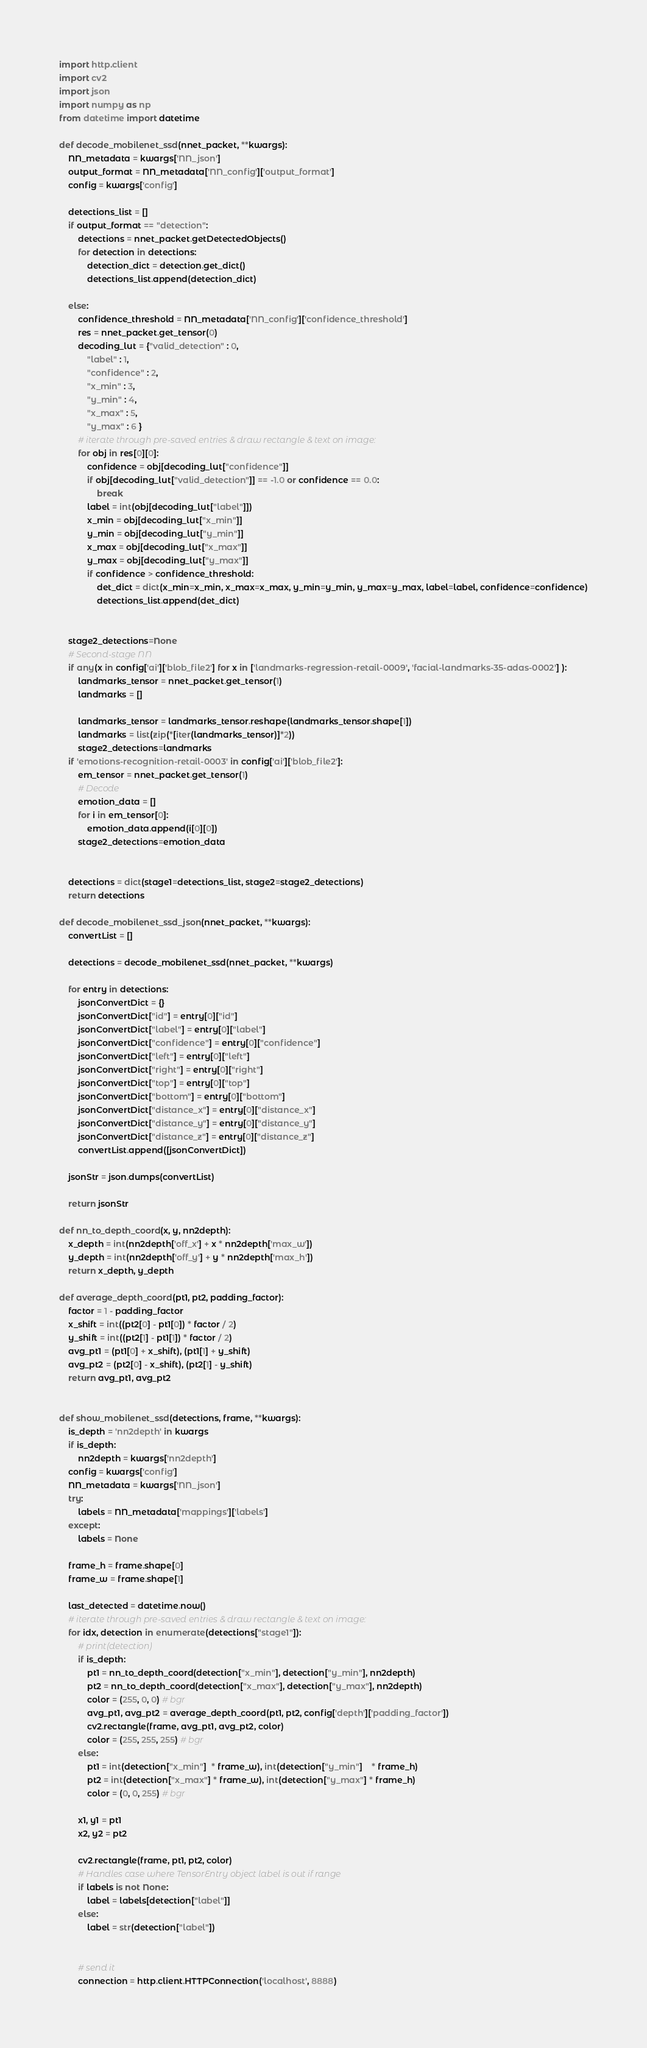<code> <loc_0><loc_0><loc_500><loc_500><_Python_>import http.client
import cv2
import json
import numpy as np
from datetime import datetime

def decode_mobilenet_ssd(nnet_packet, **kwargs):
    NN_metadata = kwargs['NN_json']
    output_format = NN_metadata['NN_config']['output_format']
    config = kwargs['config']

    detections_list = []
    if output_format == "detection":
        detections = nnet_packet.getDetectedObjects()
        for detection in detections:
            detection_dict = detection.get_dict()
            detections_list.append(detection_dict)

    else:
        confidence_threshold = NN_metadata['NN_config']['confidence_threshold']
        res = nnet_packet.get_tensor(0)
        decoding_lut = {"valid_detection" : 0,
            "label" : 1,
            "confidence" : 2,
            "x_min" : 3,
            "y_min" : 4,
            "x_max" : 5,
            "y_max" : 6 }
        # iterate through pre-saved entries & draw rectangle & text on image:
        for obj in res[0][0]:
            confidence = obj[decoding_lut["confidence"]]
            if obj[decoding_lut["valid_detection"]] == -1.0 or confidence == 0.0:
                break
            label = int(obj[decoding_lut["label"]])
            x_min = obj[decoding_lut["x_min"]]
            y_min = obj[decoding_lut["y_min"]]
            x_max = obj[decoding_lut["x_max"]]
            y_max = obj[decoding_lut["y_max"]]
            if confidence > confidence_threshold:
                det_dict = dict(x_min=x_min, x_max=x_max, y_min=y_min, y_max=y_max, label=label, confidence=confidence)
                detections_list.append(det_dict)


    stage2_detections=None
    # Second-stage NN
    if any(x in config['ai']['blob_file2'] for x in ['landmarks-regression-retail-0009', 'facial-landmarks-35-adas-0002'] ):
        landmarks_tensor = nnet_packet.get_tensor(1)
        landmarks = []

        landmarks_tensor = landmarks_tensor.reshape(landmarks_tensor.shape[1])    
        landmarks = list(zip(*[iter(landmarks_tensor)]*2))
        stage2_detections=landmarks
    if 'emotions-recognition-retail-0003' in config['ai']['blob_file2']:
        em_tensor = nnet_packet.get_tensor(1)
        # Decode
        emotion_data = []
        for i in em_tensor[0]:
            emotion_data.append(i[0][0])
        stage2_detections=emotion_data
    

    detections = dict(stage1=detections_list, stage2=stage2_detections)
    return detections

def decode_mobilenet_ssd_json(nnet_packet, **kwargs):
    convertList = []

    detections = decode_mobilenet_ssd(nnet_packet, **kwargs)

    for entry in detections:
        jsonConvertDict = {}
        jsonConvertDict["id"] = entry[0]["id"]
        jsonConvertDict["label"] = entry[0]["label"]
        jsonConvertDict["confidence"] = entry[0]["confidence"]
        jsonConvertDict["left"] = entry[0]["left"]
        jsonConvertDict["right"] = entry[0]["right"]
        jsonConvertDict["top"] = entry[0]["top"]
        jsonConvertDict["bottom"] = entry[0]["bottom"]
        jsonConvertDict["distance_x"] = entry[0]["distance_x"]
        jsonConvertDict["distance_y"] = entry[0]["distance_y"]
        jsonConvertDict["distance_z"] = entry[0]["distance_z"]
        convertList.append([jsonConvertDict])

    jsonStr = json.dumps(convertList)

    return jsonStr

def nn_to_depth_coord(x, y, nn2depth):
    x_depth = int(nn2depth['off_x'] + x * nn2depth['max_w'])
    y_depth = int(nn2depth['off_y'] + y * nn2depth['max_h'])
    return x_depth, y_depth

def average_depth_coord(pt1, pt2, padding_factor):
    factor = 1 - padding_factor
    x_shift = int((pt2[0] - pt1[0]) * factor / 2)
    y_shift = int((pt2[1] - pt1[1]) * factor / 2)
    avg_pt1 = (pt1[0] + x_shift), (pt1[1] + y_shift)
    avg_pt2 = (pt2[0] - x_shift), (pt2[1] - y_shift)
    return avg_pt1, avg_pt2


def show_mobilenet_ssd(detections, frame, **kwargs):
    is_depth = 'nn2depth' in kwargs
    if is_depth:
        nn2depth = kwargs['nn2depth']
    config = kwargs['config']
    NN_metadata = kwargs['NN_json']
    try:
        labels = NN_metadata['mappings']['labels']
    except:
        labels = None
    
    frame_h = frame.shape[0]
    frame_w = frame.shape[1]

    last_detected = datetime.now()
    # iterate through pre-saved entries & draw rectangle & text on image:
    for idx, detection in enumerate(detections["stage1"]):
        # print(detection)
        if is_depth:
            pt1 = nn_to_depth_coord(detection["x_min"], detection["y_min"], nn2depth)
            pt2 = nn_to_depth_coord(detection["x_max"], detection["y_max"], nn2depth)
            color = (255, 0, 0) # bgr
            avg_pt1, avg_pt2 = average_depth_coord(pt1, pt2, config['depth']['padding_factor'])
            cv2.rectangle(frame, avg_pt1, avg_pt2, color)
            color = (255, 255, 255) # bgr
        else:
            pt1 = int(detection["x_min"]  * frame_w), int(detection["y_min"]    * frame_h)
            pt2 = int(detection["x_max"] * frame_w), int(detection["y_max"] * frame_h)
            color = (0, 0, 255) # bgr

        x1, y1 = pt1
        x2, y2 = pt2

        cv2.rectangle(frame, pt1, pt2, color)
        # Handles case where TensorEntry object label is out if range
        if labels is not None:
            label = labels[detection["label"]]
        else:
            label = str(detection["label"])


        # send it
        connection = http.client.HTTPConnection('localhost', 8888)</code> 